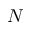Convert formula to latex. <formula><loc_0><loc_0><loc_500><loc_500>N</formula> 